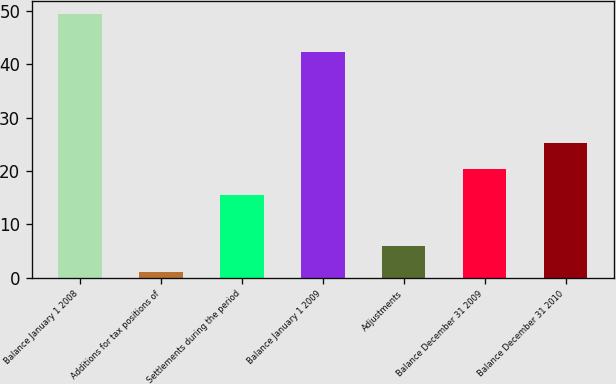<chart> <loc_0><loc_0><loc_500><loc_500><bar_chart><fcel>Balance January 1 2008<fcel>Additions for tax positions of<fcel>Settlements during the period<fcel>Balance January 1 2009<fcel>Adjustments<fcel>Balance December 31 2009<fcel>Balance December 31 2010<nl><fcel>49.4<fcel>1<fcel>15.52<fcel>42.4<fcel>5.84<fcel>20.36<fcel>25.2<nl></chart> 